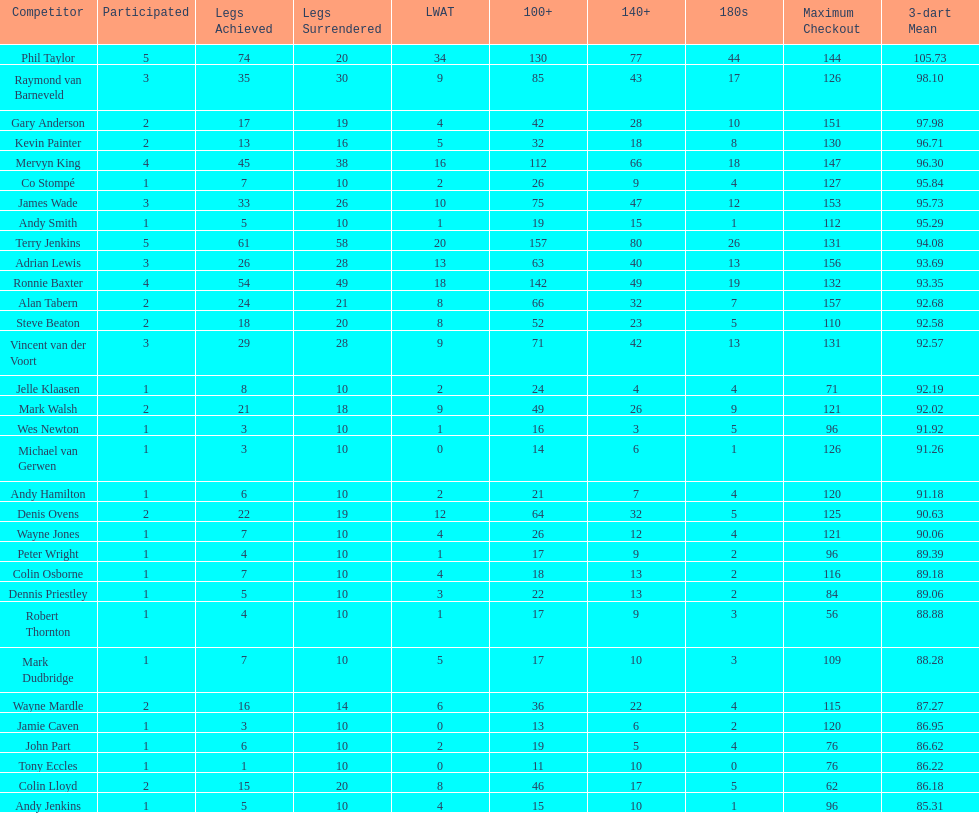What are the number of legs lost by james wade? 26. 